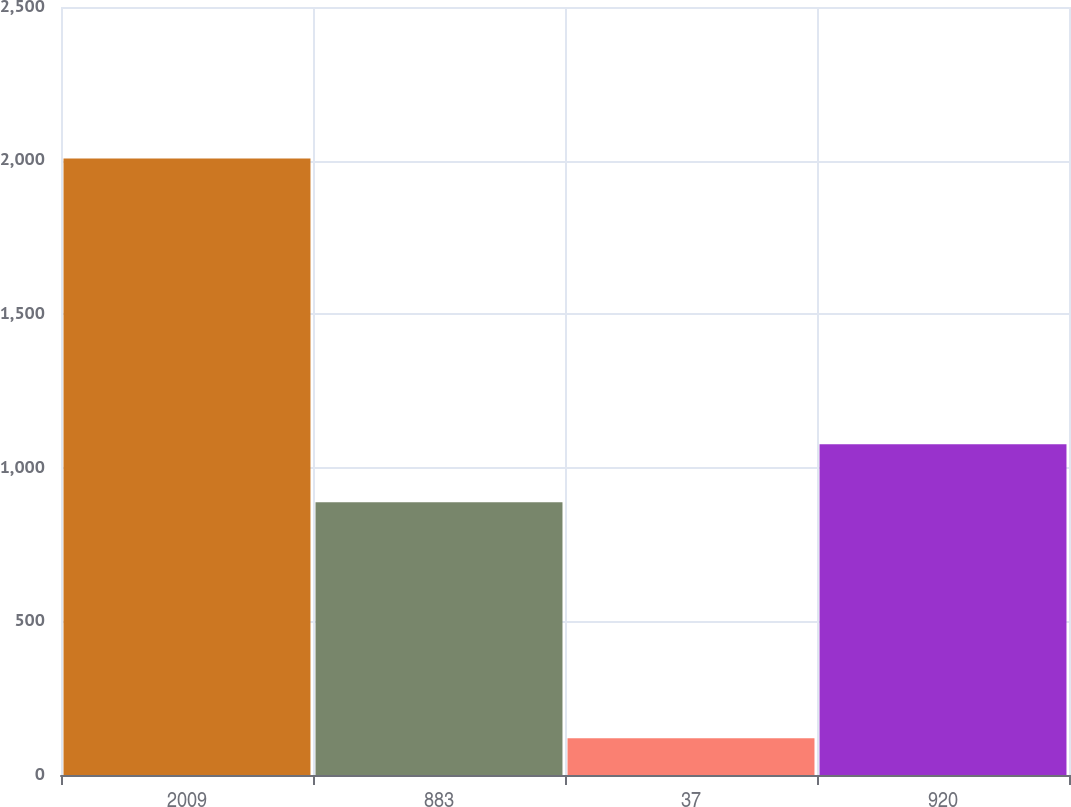Convert chart. <chart><loc_0><loc_0><loc_500><loc_500><bar_chart><fcel>2009<fcel>883<fcel>37<fcel>920<nl><fcel>2007<fcel>888<fcel>120<fcel>1076.7<nl></chart> 